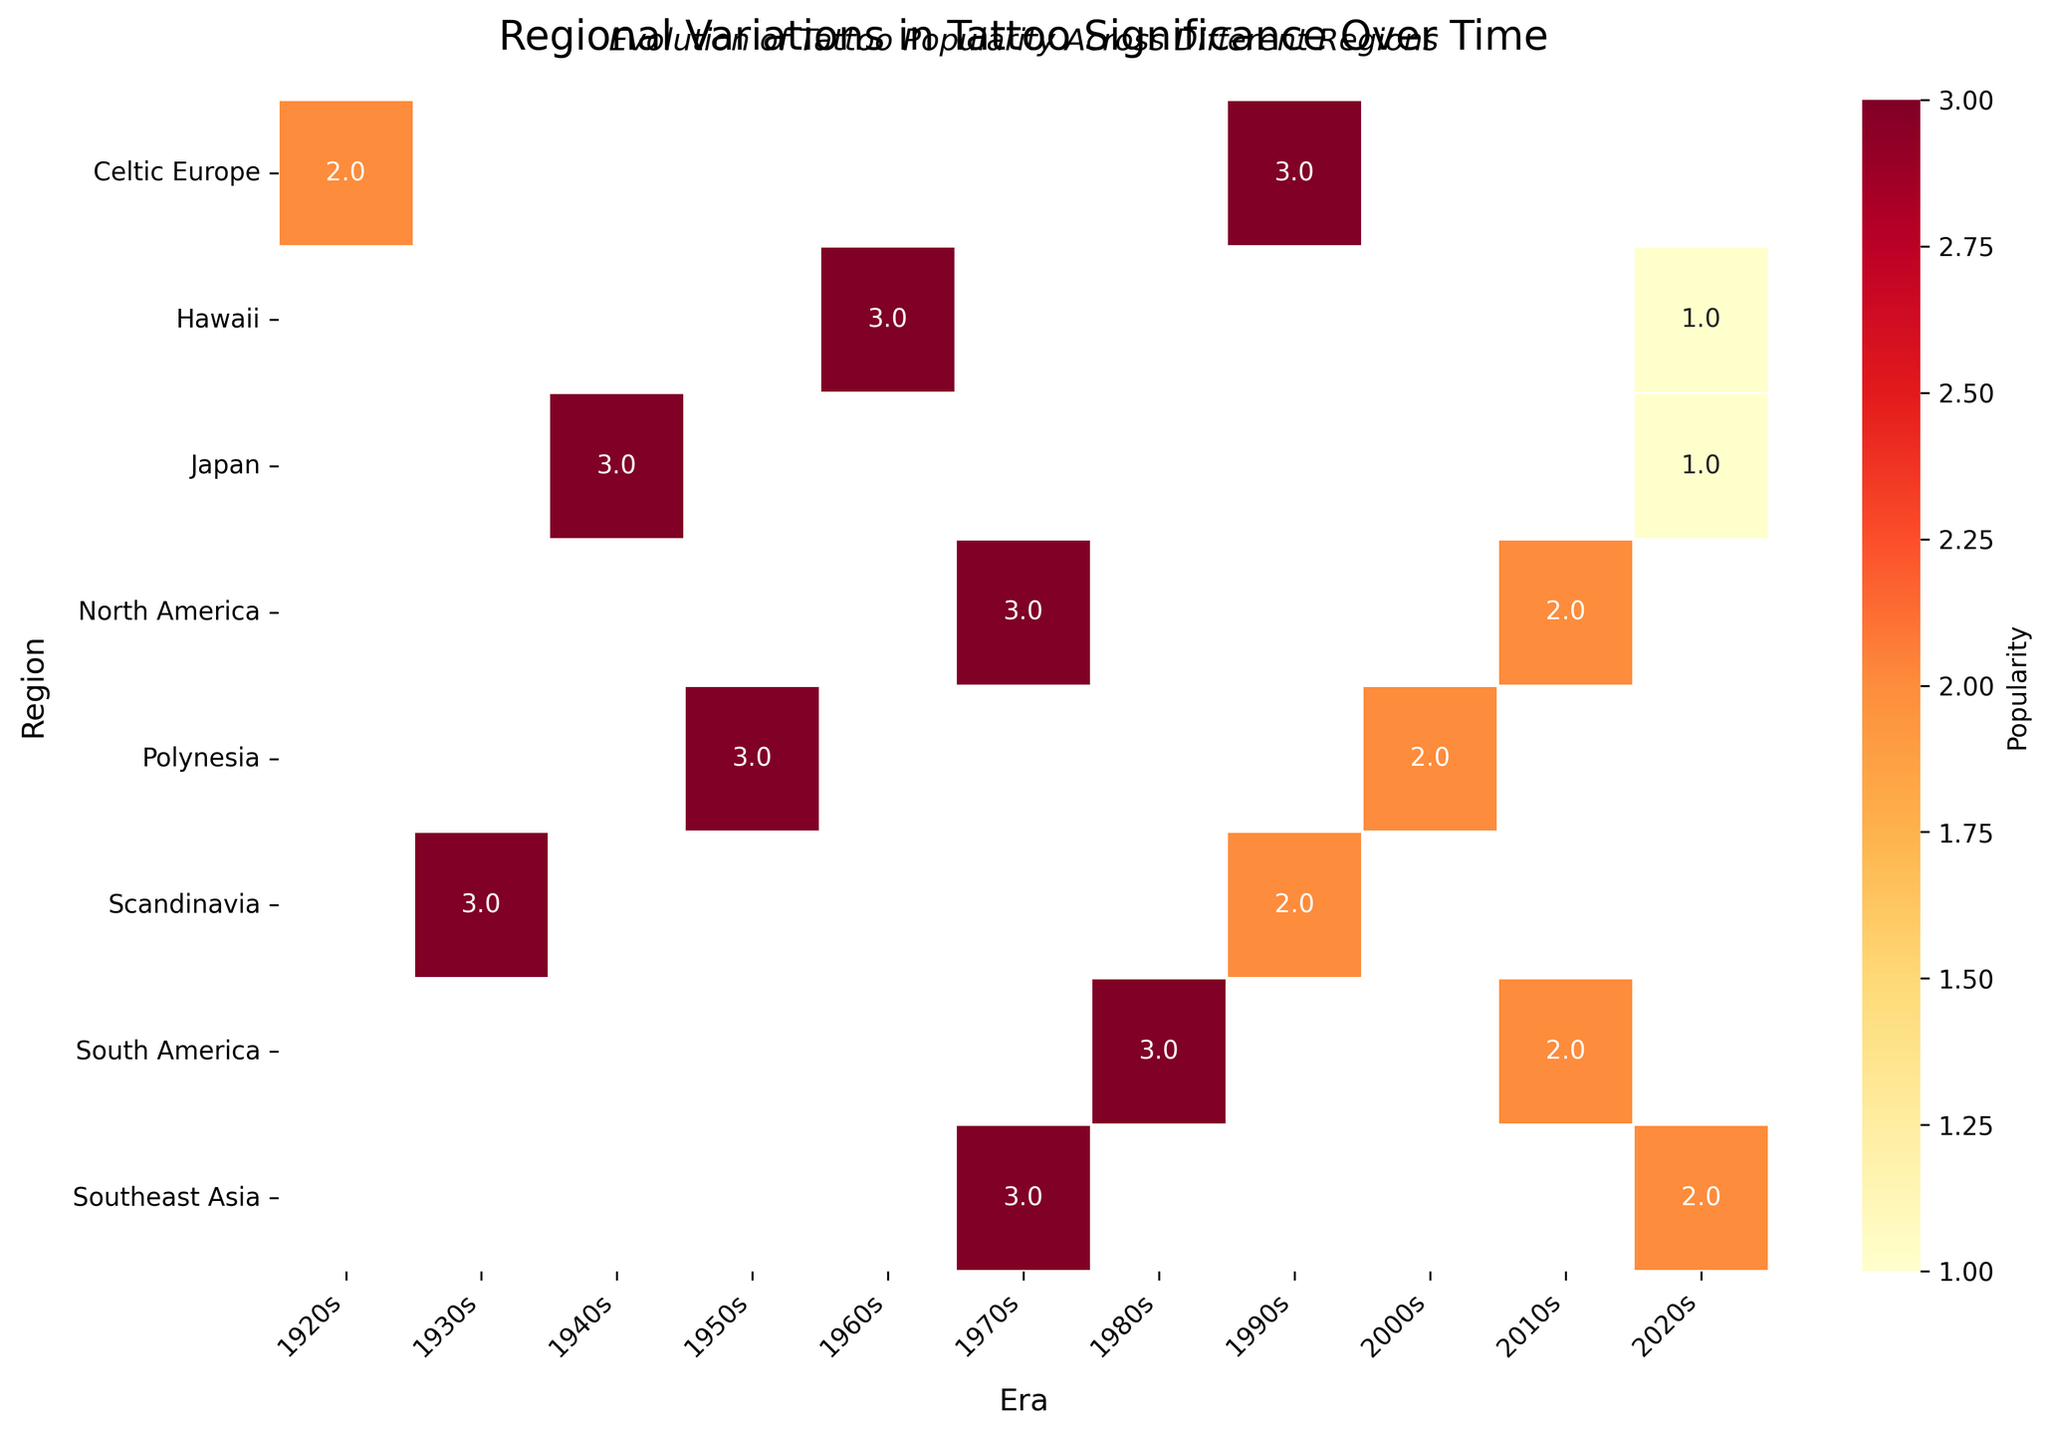What is the title of the heatmap? The title is written at the top of the heatmap and is larger in font size. It reads, "Regional Variations in Tattoo Significance Over Time."
Answer: Regional Variations in Tattoo Significance Over Time What's the color range used in the heatmap to represent popularity? The color range of the heatmap varies from light yellow to dark red. The light yellow indicates lower popularity, and dark red indicates higher popularity.
Answer: From light yellow to dark red Which region in the 1950s shows the highest popularity for tattoos? By looking at the darkest red cell in the 1950s column, we can identify the Polynesia region as having the highest popularity for tattoos.
Answer: Polynesia How has the popularity of the Sak Yant tattoo in Southeast Asia changed from the 1970s to the 2020s? By comparing the 1970s and 2020s columns in the Southeast Asia row, we can see the shift from the darker color in the 1970s (high popularity) to a lighter color in the 2020s (medium popularity).
Answer: From high to medium Which region experienced a decline in the popularity of the Eagle Freedom tattoo from the 1970s to the 2010s? By examining the North America row, the color changes from dark red in the 1970s to a lighter shade in the 2010s.
Answer: North America Calculate the average popularity score for the Celtic Knot tattoo in Celtic Europe across all eras shown. Celtic Europe has medium popularity in the 1920s (score 2) and high popularity in the 1990s (score 3). The average is (2+3)/2 = 2.5.
Answer: 2.5 In which era did tattoos in Hawaii (Honus) have the lowest popularity? By comparing the popularity in all eras for Hawaii (Honus), the lightest color appears in the 2020s, indicating the lowest popularity.
Answer: 2020s Compare the change in popularity of the Koi Fish tattoo in Japan from the 1940s to the 2020s with the change in the Honus tattoo in Hawaii from the 1960s to the 2020s. Which tattoo saw a larger decrease? Koi Fish in Japan goes from high (3) to low (1), a decrease of 2 points. Honus in Hawaii goes from high (3) to low (1), also a decrease of 2 points. Both tattoos saw the same decrease.
Answer: Same decrease Which region has the most consistent popularity for tattoos over different eras? By observing the colors across different eras for each region, Polynesia, the overall color difference between eras is less pronounced, showing a consistent popularity trend.
Answer: Polynesia 